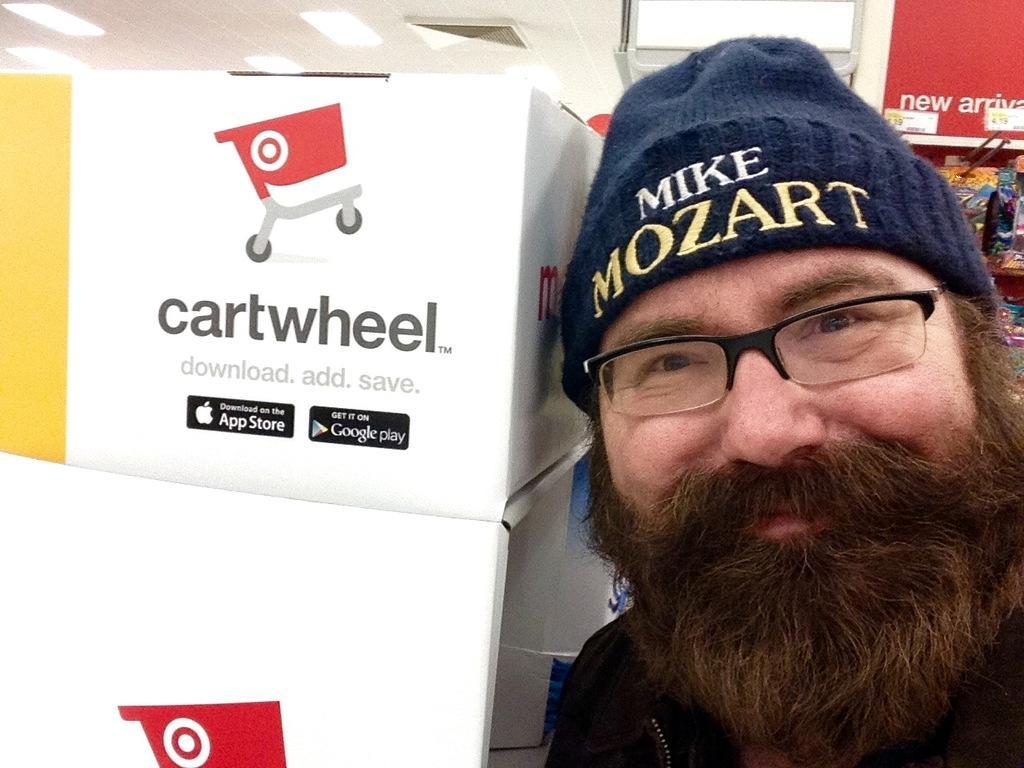How would you summarize this image in a sentence or two? In this image we can see a person and beside the person there is a box with text on the box and there are few objects in the background and lights attached to the ceiling. 